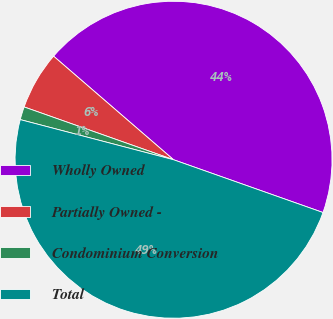Convert chart to OTSL. <chart><loc_0><loc_0><loc_500><loc_500><pie_chart><fcel>Wholly Owned<fcel>Partially Owned -<fcel>Condominium Conversion<fcel>Total<nl><fcel>44.07%<fcel>5.93%<fcel>1.33%<fcel>48.67%<nl></chart> 